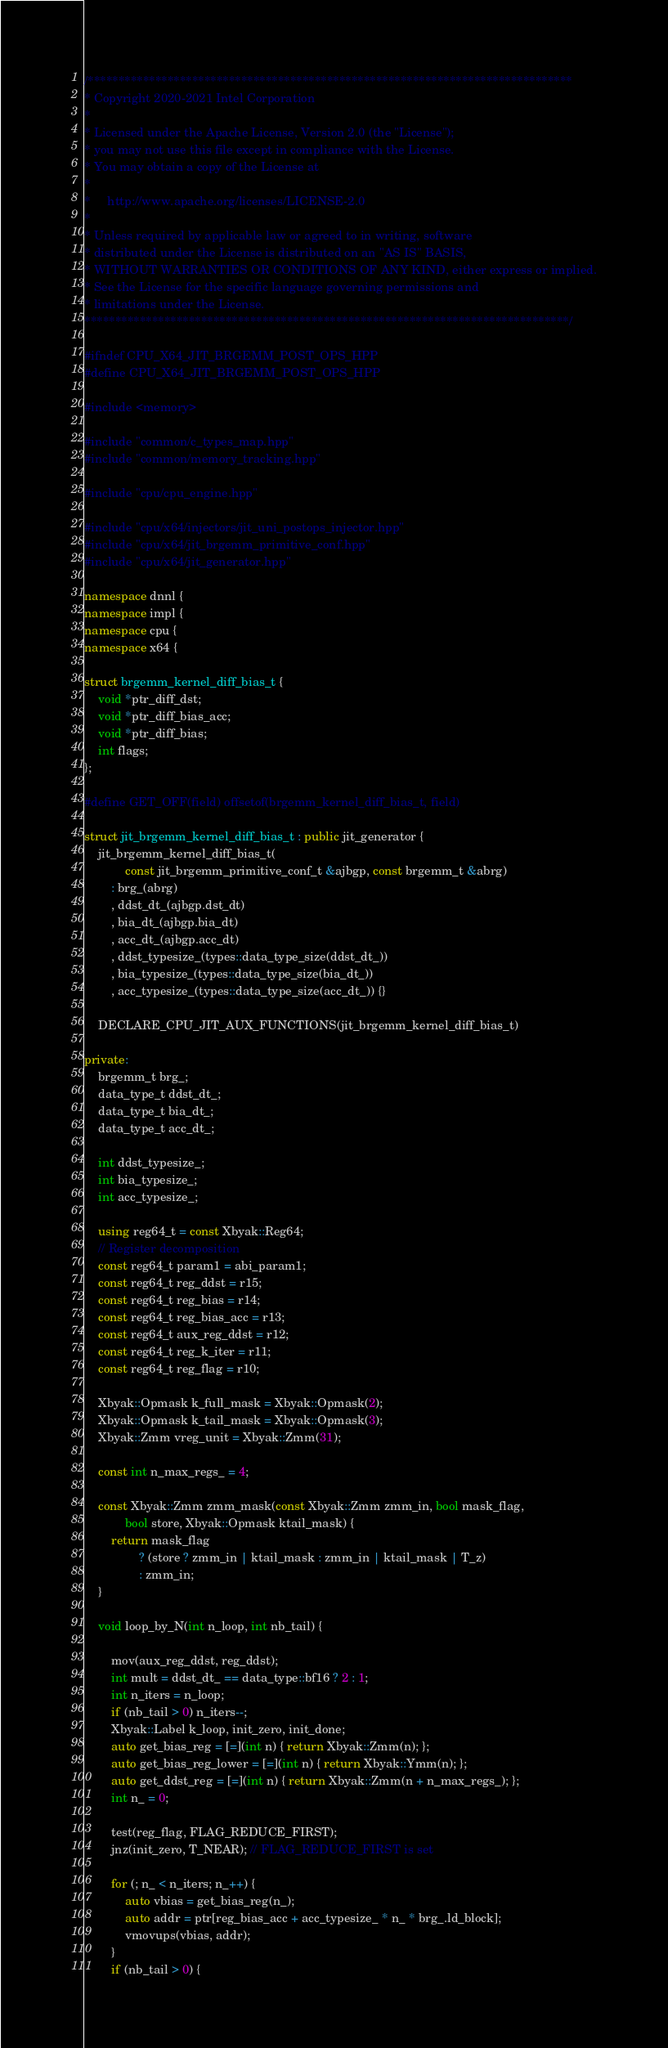<code> <loc_0><loc_0><loc_500><loc_500><_C++_>/*******************************************************************************
* Copyright 2020-2021 Intel Corporation
*
* Licensed under the Apache License, Version 2.0 (the "License");
* you may not use this file except in compliance with the License.
* You may obtain a copy of the License at
*
*     http://www.apache.org/licenses/LICENSE-2.0
*
* Unless required by applicable law or agreed to in writing, software
* distributed under the License is distributed on an "AS IS" BASIS,
* WITHOUT WARRANTIES OR CONDITIONS OF ANY KIND, either express or implied.
* See the License for the specific language governing permissions and
* limitations under the License.
*******************************************************************************/

#ifndef CPU_X64_JIT_BRGEMM_POST_OPS_HPP
#define CPU_X64_JIT_BRGEMM_POST_OPS_HPP

#include <memory>

#include "common/c_types_map.hpp"
#include "common/memory_tracking.hpp"

#include "cpu/cpu_engine.hpp"

#include "cpu/x64/injectors/jit_uni_postops_injector.hpp"
#include "cpu/x64/jit_brgemm_primitive_conf.hpp"
#include "cpu/x64/jit_generator.hpp"

namespace dnnl {
namespace impl {
namespace cpu {
namespace x64 {

struct brgemm_kernel_diff_bias_t {
    void *ptr_diff_dst;
    void *ptr_diff_bias_acc;
    void *ptr_diff_bias;
    int flags;
};

#define GET_OFF(field) offsetof(brgemm_kernel_diff_bias_t, field)

struct jit_brgemm_kernel_diff_bias_t : public jit_generator {
    jit_brgemm_kernel_diff_bias_t(
            const jit_brgemm_primitive_conf_t &ajbgp, const brgemm_t &abrg)
        : brg_(abrg)
        , ddst_dt_(ajbgp.dst_dt)
        , bia_dt_(ajbgp.bia_dt)
        , acc_dt_(ajbgp.acc_dt)
        , ddst_typesize_(types::data_type_size(ddst_dt_))
        , bia_typesize_(types::data_type_size(bia_dt_))
        , acc_typesize_(types::data_type_size(acc_dt_)) {}

    DECLARE_CPU_JIT_AUX_FUNCTIONS(jit_brgemm_kernel_diff_bias_t)

private:
    brgemm_t brg_;
    data_type_t ddst_dt_;
    data_type_t bia_dt_;
    data_type_t acc_dt_;

    int ddst_typesize_;
    int bia_typesize_;
    int acc_typesize_;

    using reg64_t = const Xbyak::Reg64;
    // Register decomposition
    const reg64_t param1 = abi_param1;
    const reg64_t reg_ddst = r15;
    const reg64_t reg_bias = r14;
    const reg64_t reg_bias_acc = r13;
    const reg64_t aux_reg_ddst = r12;
    const reg64_t reg_k_iter = r11;
    const reg64_t reg_flag = r10;

    Xbyak::Opmask k_full_mask = Xbyak::Opmask(2);
    Xbyak::Opmask k_tail_mask = Xbyak::Opmask(3);
    Xbyak::Zmm vreg_unit = Xbyak::Zmm(31);

    const int n_max_regs_ = 4;

    const Xbyak::Zmm zmm_mask(const Xbyak::Zmm zmm_in, bool mask_flag,
            bool store, Xbyak::Opmask ktail_mask) {
        return mask_flag
                ? (store ? zmm_in | ktail_mask : zmm_in | ktail_mask | T_z)
                : zmm_in;
    }

    void loop_by_N(int n_loop, int nb_tail) {

        mov(aux_reg_ddst, reg_ddst);
        int mult = ddst_dt_ == data_type::bf16 ? 2 : 1;
        int n_iters = n_loop;
        if (nb_tail > 0) n_iters--;
        Xbyak::Label k_loop, init_zero, init_done;
        auto get_bias_reg = [=](int n) { return Xbyak::Zmm(n); };
        auto get_bias_reg_lower = [=](int n) { return Xbyak::Ymm(n); };
        auto get_ddst_reg = [=](int n) { return Xbyak::Zmm(n + n_max_regs_); };
        int n_ = 0;

        test(reg_flag, FLAG_REDUCE_FIRST);
        jnz(init_zero, T_NEAR); // FLAG_REDUCE_FIRST is set

        for (; n_ < n_iters; n_++) {
            auto vbias = get_bias_reg(n_);
            auto addr = ptr[reg_bias_acc + acc_typesize_ * n_ * brg_.ld_block];
            vmovups(vbias, addr);
        }
        if (nb_tail > 0) {</code> 